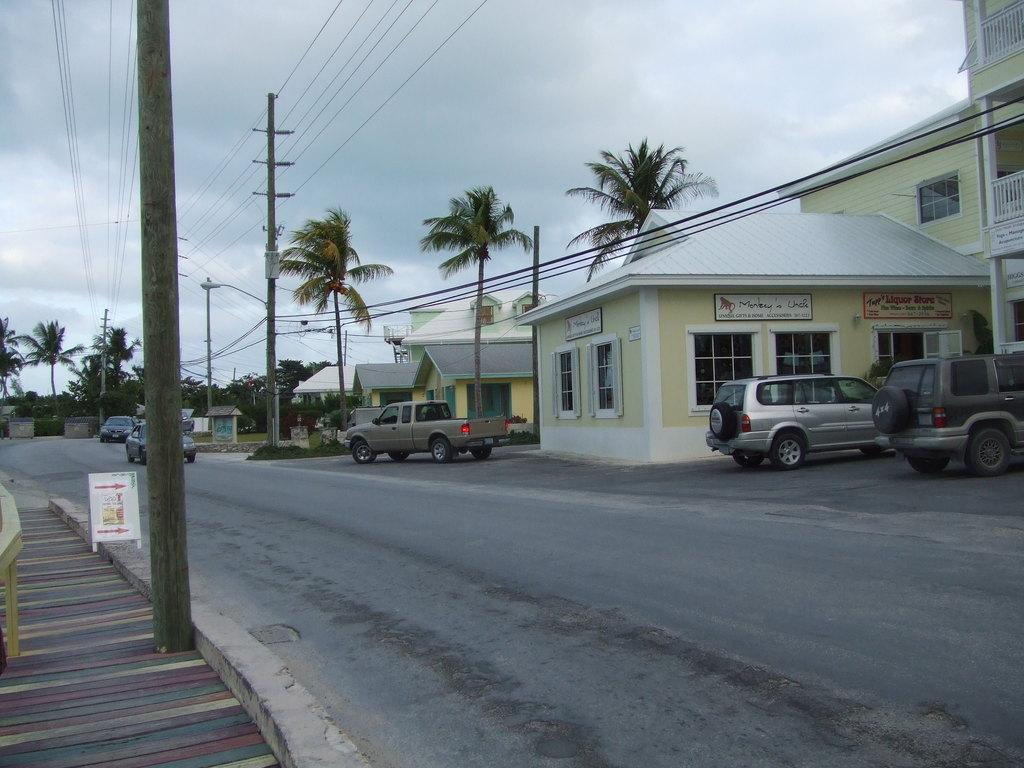What can be seen on the road in the image? There are vehicles on the road in the image. What type of structures are visible in the image? There are buildings in the image. What are the name boards used for in the image? Name boards are present in the image to provide information or directions. What are the electric poles supporting in the image? Electric poles are visible in the image, supporting electrical wires. What objects can be seen in the image? There are objects in the image, such as vehicles, buildings, and name boards. What type of vegetation is visible in the background of the image? Trees are present in the background of the image. What is visible in the sky in the background of the image? The sky is visible in the background of the image. How many leaves can be seen on the clover in the image? There is no clover present in the image. 